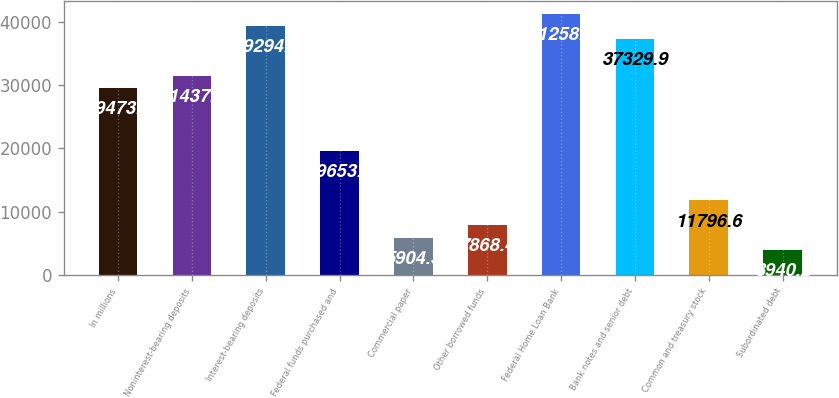Convert chart. <chart><loc_0><loc_0><loc_500><loc_500><bar_chart><fcel>In millions<fcel>Noninterest-bearing deposits<fcel>Interest-bearing deposits<fcel>Federal funds purchased and<fcel>Commercial paper<fcel>Other borrowed funds<fcel>Federal Home Loan Bank<fcel>Bank notes and senior debt<fcel>Common and treasury stock<fcel>Subordinated debt<nl><fcel>29473.5<fcel>31437.6<fcel>39294<fcel>19653<fcel>5904.3<fcel>7868.4<fcel>41258.1<fcel>37329.9<fcel>11796.6<fcel>3940.2<nl></chart> 